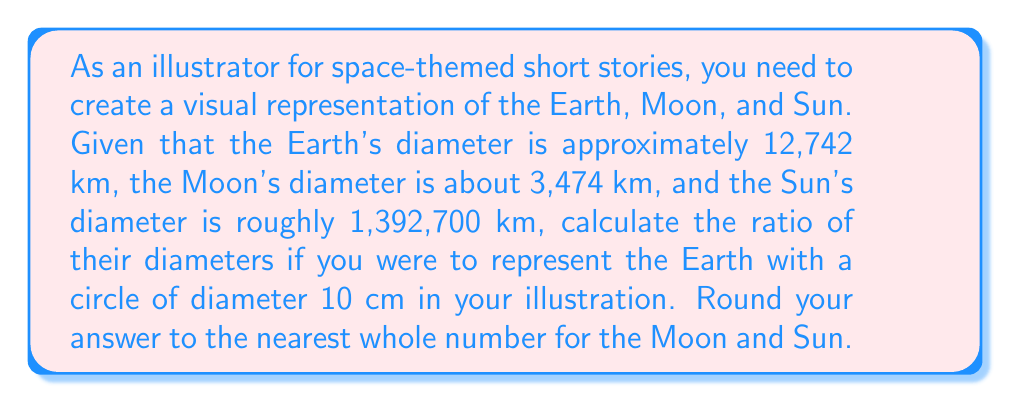Can you solve this math problem? To solve this problem, we need to establish a scale based on the Earth's diameter and then apply it to the Moon and Sun. Let's break it down step-by-step:

1. Set up the scale:
   Earth's actual diameter = 12,742 km
   Earth's diameter in illustration = 10 cm

   Scale factor = $\frac{10 \text{ cm}}{12,742 \text{ km}} = \frac{10}{12,742,000} \text{ cm/km}$

2. Calculate the Moon's diameter in the illustration:
   Moon's actual diameter = 3,474 km
   Moon's illustration diameter = $3,474 \times \frac{10}{12,742,000} \text{ cm} = 2.73 \text{ cm}$

3. Calculate the Sun's diameter in the illustration:
   Sun's actual diameter = 1,392,700 km
   Sun's illustration diameter = $1,392,700 \times \frac{10}{12,742,000} \text{ cm} = 1,093.0 \text{ cm}$

4. Express the ratio of diameters:
   Earth : Moon : Sun = 10 : 2.73 : 1093.0

5. Round the Moon and Sun values to the nearest whole number:
   Earth : Moon : Sun = 10 : 3 : 1093

Therefore, the ratio of diameters in the illustration should be 10 : 3 : 1093 for Earth : Moon : Sun.
Answer: 10 : 3 : 1093 